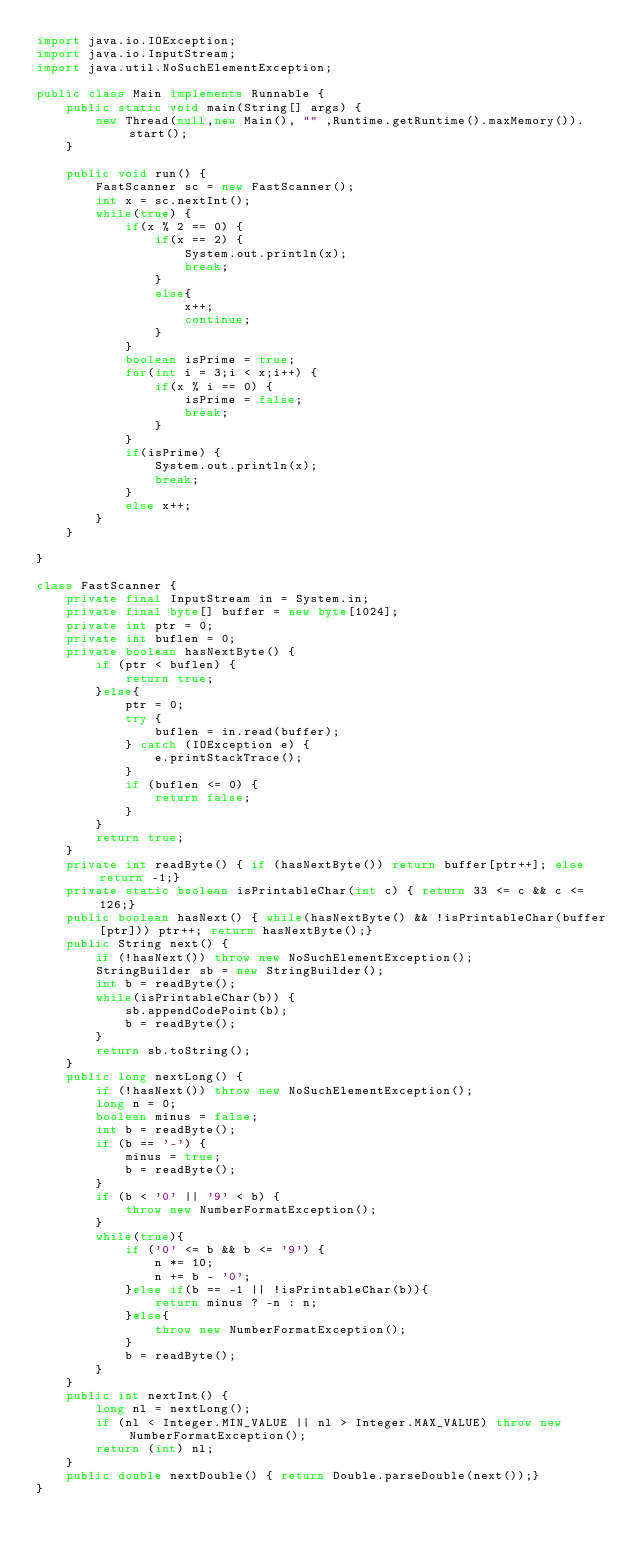Convert code to text. <code><loc_0><loc_0><loc_500><loc_500><_Java_>import java.io.IOException;
import java.io.InputStream;
import java.util.NoSuchElementException;

public class Main implements Runnable {
    public static void main(String[] args) {
        new Thread(null,new Main(), "" ,Runtime.getRuntime().maxMemory()).start();
    }

    public void run() {
        FastScanner sc = new FastScanner();
        int x = sc.nextInt();
        while(true) {
            if(x % 2 == 0) {
                if(x == 2) {
                    System.out.println(x);
                    break;
                }
                else{
                    x++;
                    continue;
                }
            }
            boolean isPrime = true;
            for(int i = 3;i < x;i++) {
                if(x % i == 0) {
                    isPrime = false;
                    break;
                }
            }
            if(isPrime) {
                System.out.println(x);
                break;
            }
            else x++;
        }
    }

}

class FastScanner {
    private final InputStream in = System.in;
    private final byte[] buffer = new byte[1024];
    private int ptr = 0;
    private int buflen = 0;
    private boolean hasNextByte() {
        if (ptr < buflen) {
            return true;
        }else{
            ptr = 0;
            try {
                buflen = in.read(buffer);
            } catch (IOException e) {
                e.printStackTrace();
            }
            if (buflen <= 0) {
                return false;
            }
        }
        return true;
    }
    private int readByte() { if (hasNextByte()) return buffer[ptr++]; else return -1;}
    private static boolean isPrintableChar(int c) { return 33 <= c && c <= 126;}
    public boolean hasNext() { while(hasNextByte() && !isPrintableChar(buffer[ptr])) ptr++; return hasNextByte();}
    public String next() {
        if (!hasNext()) throw new NoSuchElementException();
        StringBuilder sb = new StringBuilder();
        int b = readByte();
        while(isPrintableChar(b)) {
            sb.appendCodePoint(b);
            b = readByte();
        }
        return sb.toString();
    }
    public long nextLong() {
        if (!hasNext()) throw new NoSuchElementException();
        long n = 0;
        boolean minus = false;
        int b = readByte();
        if (b == '-') {
            minus = true;
            b = readByte();
        }
        if (b < '0' || '9' < b) {
            throw new NumberFormatException();
        }
        while(true){
            if ('0' <= b && b <= '9') {
                n *= 10;
                n += b - '0';
            }else if(b == -1 || !isPrintableChar(b)){
                return minus ? -n : n;
            }else{
                throw new NumberFormatException();
            }
            b = readByte();
        }
    }
    public int nextInt() {
        long nl = nextLong();
        if (nl < Integer.MIN_VALUE || nl > Integer.MAX_VALUE) throw new NumberFormatException();
        return (int) nl;
    }
    public double nextDouble() { return Double.parseDouble(next());}
}</code> 